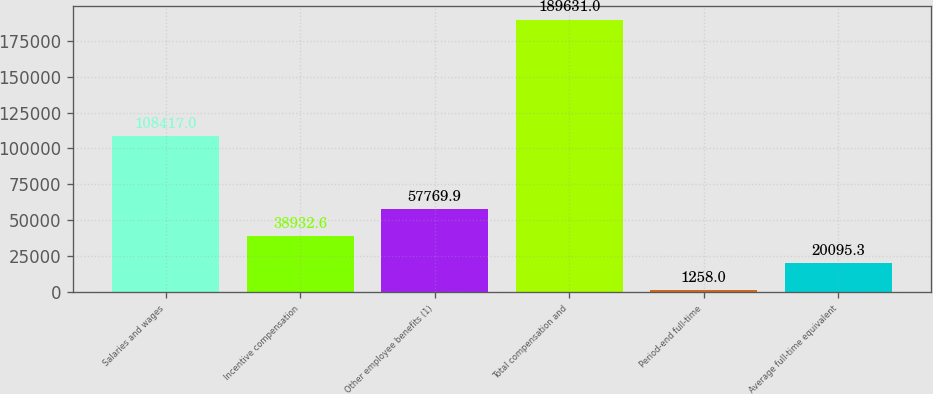<chart> <loc_0><loc_0><loc_500><loc_500><bar_chart><fcel>Salaries and wages<fcel>Incentive compensation<fcel>Other employee benefits (1)<fcel>Total compensation and<fcel>Period-end full-time<fcel>Average full-time equivalent<nl><fcel>108417<fcel>38932.6<fcel>57769.9<fcel>189631<fcel>1258<fcel>20095.3<nl></chart> 